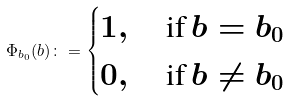<formula> <loc_0><loc_0><loc_500><loc_500>\Phi _ { b _ { 0 } } ( b ) \colon = \begin{cases} 1 , \quad \text {if} \, b = b _ { 0 } \\ 0 , \quad \text {if} \, b \neq b _ { 0 } \end{cases}</formula> 